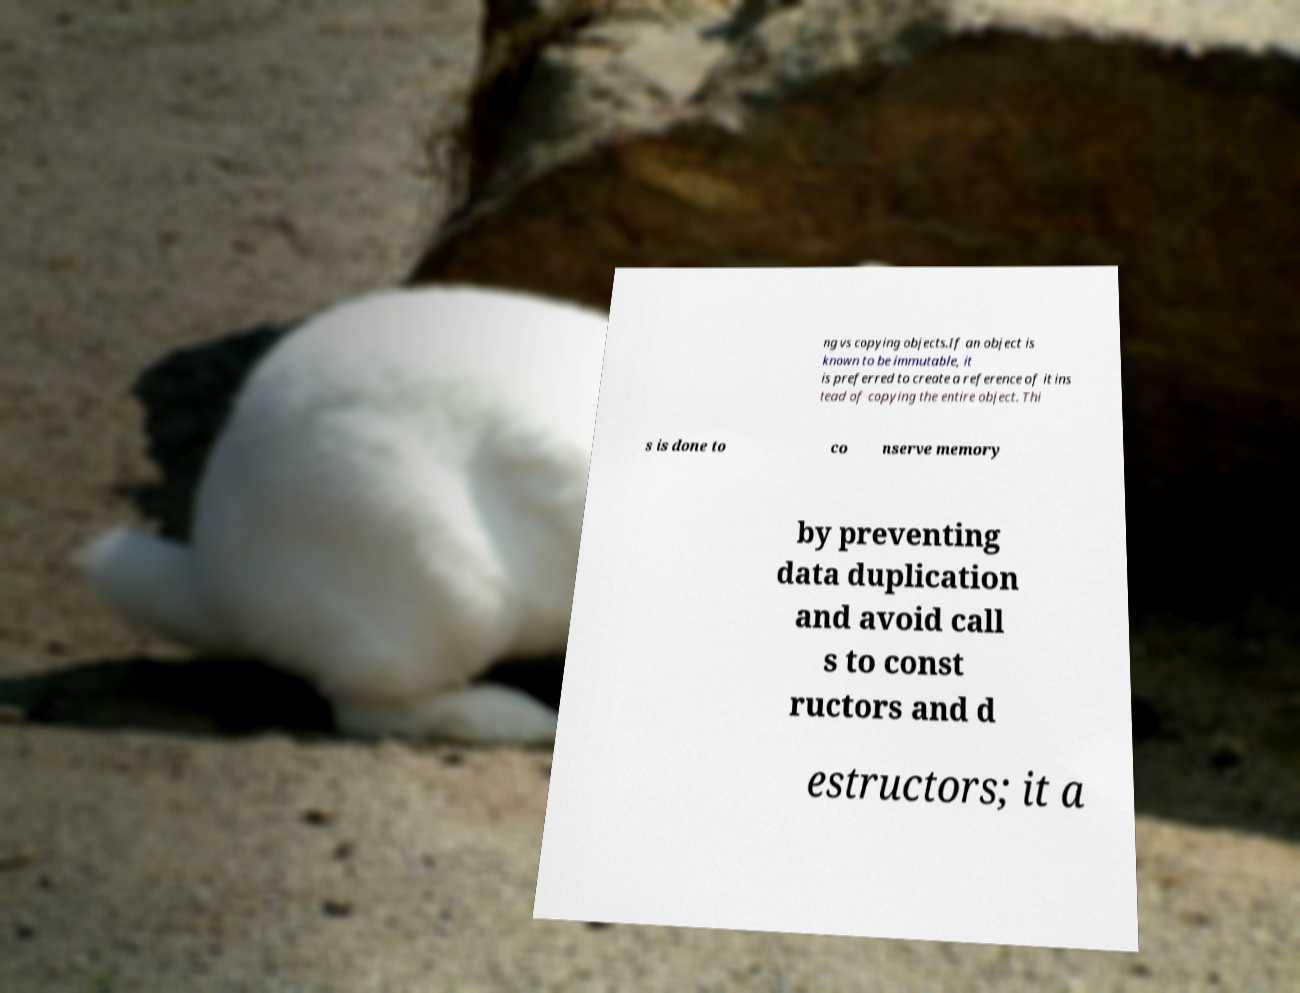For documentation purposes, I need the text within this image transcribed. Could you provide that? ng vs copying objects.If an object is known to be immutable, it is preferred to create a reference of it ins tead of copying the entire object. Thi s is done to co nserve memory by preventing data duplication and avoid call s to const ructors and d estructors; it a 